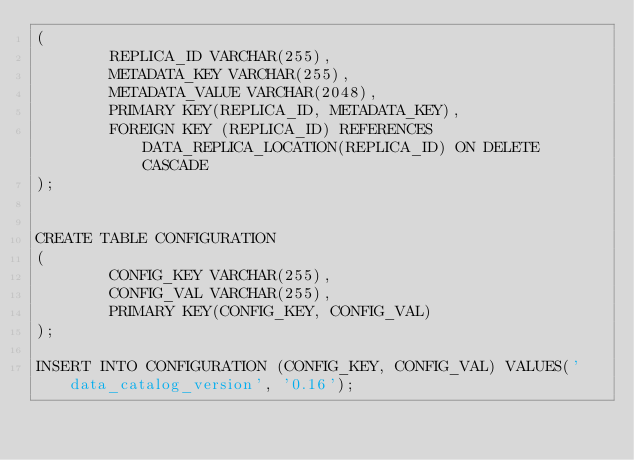Convert code to text. <code><loc_0><loc_0><loc_500><loc_500><_SQL_>(
        REPLICA_ID VARCHAR(255),
        METADATA_KEY VARCHAR(255),
        METADATA_VALUE VARCHAR(2048),
        PRIMARY KEY(REPLICA_ID, METADATA_KEY),
        FOREIGN KEY (REPLICA_ID) REFERENCES DATA_REPLICA_LOCATION(REPLICA_ID) ON DELETE CASCADE
);


CREATE TABLE CONFIGURATION
(
        CONFIG_KEY VARCHAR(255),
        CONFIG_VAL VARCHAR(255),
        PRIMARY KEY(CONFIG_KEY, CONFIG_VAL)
);

INSERT INTO CONFIGURATION (CONFIG_KEY, CONFIG_VAL) VALUES('data_catalog_version', '0.16');</code> 